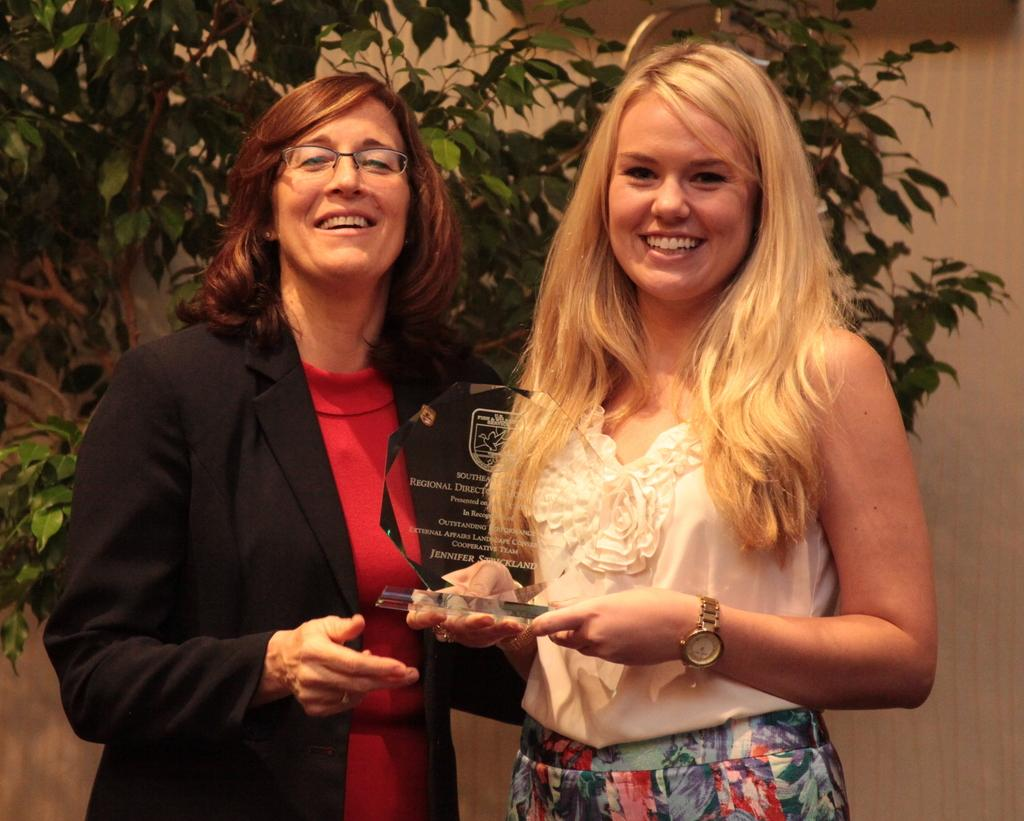How many people are present in the image? There are two persons in the image. What is the woman holding in the image? The woman is holding an award. What can be seen on the backside of the image? There is a plant and a wall visible on the backside of the image. What type of mailbox is present in the image? There is no mailbox present in the image. How many people are walking in the image? The image does not show any people walking; it only shows two people standing. 